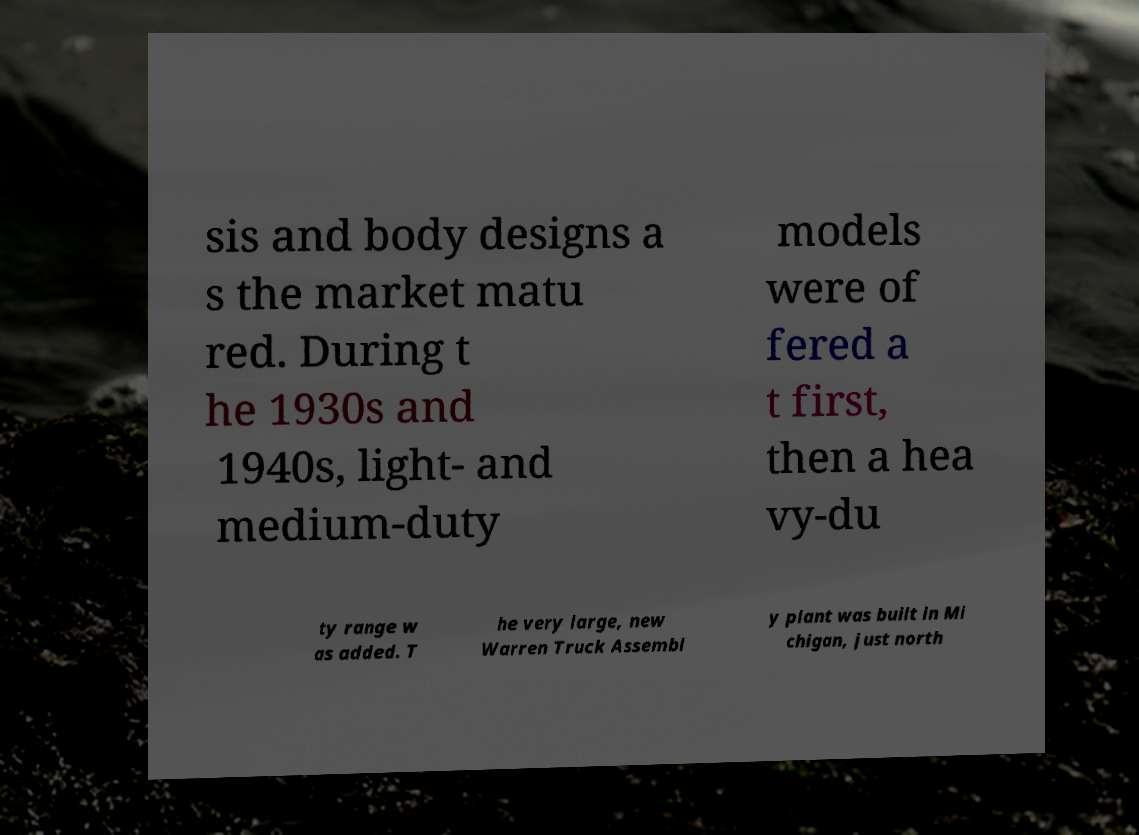I need the written content from this picture converted into text. Can you do that? sis and body designs a s the market matu red. During t he 1930s and 1940s, light- and medium-duty models were of fered a t first, then a hea vy-du ty range w as added. T he very large, new Warren Truck Assembl y plant was built in Mi chigan, just north 